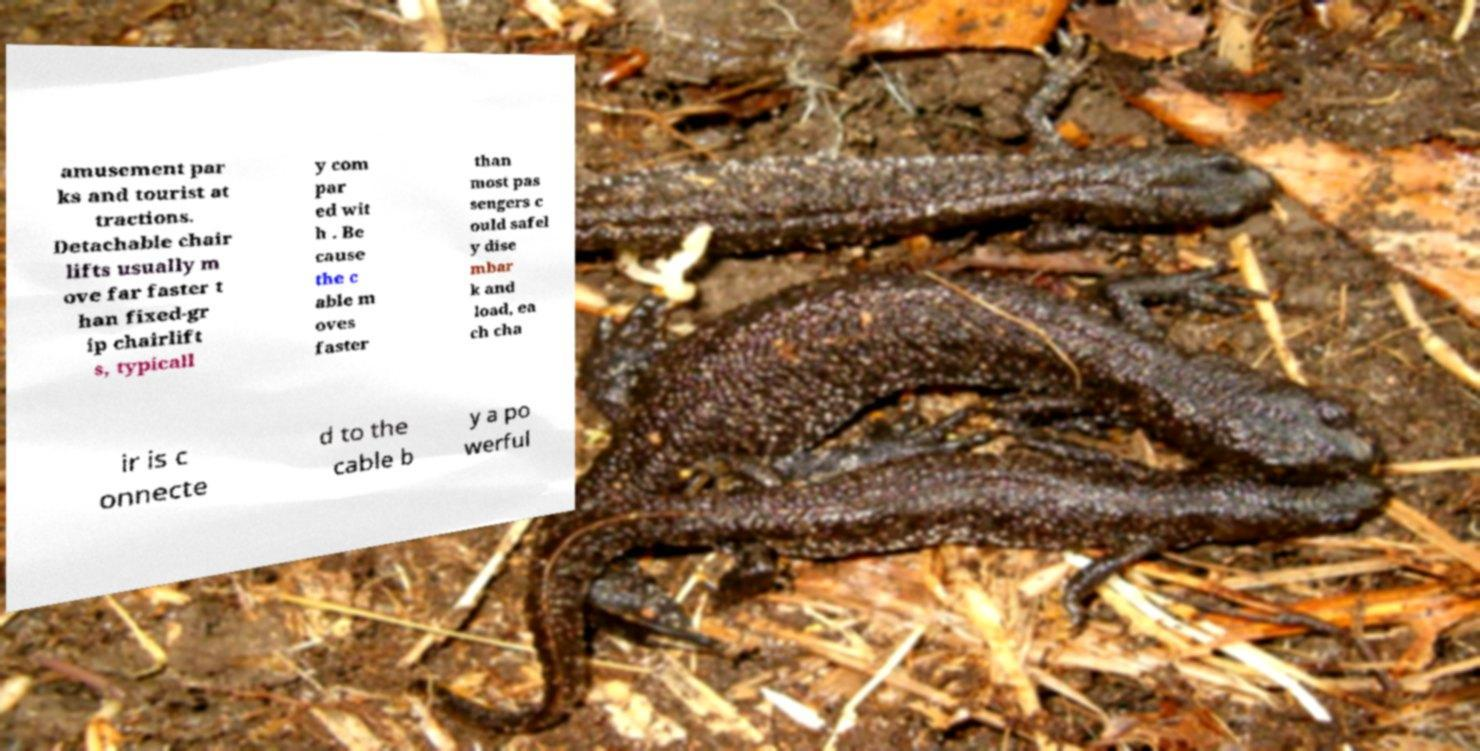Can you accurately transcribe the text from the provided image for me? amusement par ks and tourist at tractions. Detachable chair lifts usually m ove far faster t han fixed-gr ip chairlift s, typicall y com par ed wit h . Be cause the c able m oves faster than most pas sengers c ould safel y dise mbar k and load, ea ch cha ir is c onnecte d to the cable b y a po werful 